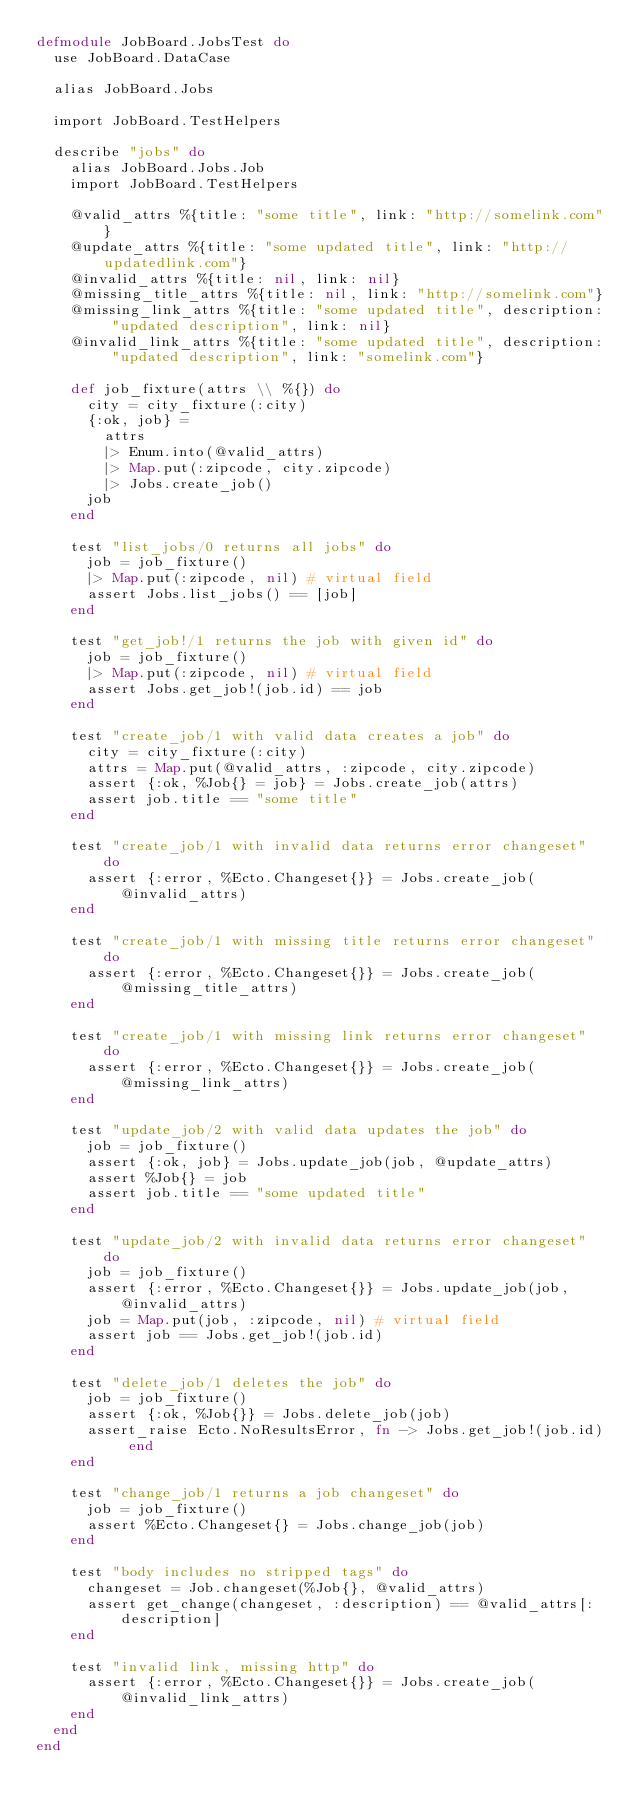<code> <loc_0><loc_0><loc_500><loc_500><_Elixir_>defmodule JobBoard.JobsTest do
  use JobBoard.DataCase

  alias JobBoard.Jobs

  import JobBoard.TestHelpers

  describe "jobs" do
    alias JobBoard.Jobs.Job
    import JobBoard.TestHelpers

    @valid_attrs %{title: "some title", link: "http://somelink.com"}
    @update_attrs %{title: "some updated title", link: "http://updatedlink.com"}
    @invalid_attrs %{title: nil, link: nil}
    @missing_title_attrs %{title: nil, link: "http://somelink.com"}
    @missing_link_attrs %{title: "some updated title", description: "updated description", link: nil}
    @invalid_link_attrs %{title: "some updated title", description: "updated description", link: "somelink.com"}

    def job_fixture(attrs \\ %{}) do
      city = city_fixture(:city)
      {:ok, job} =
        attrs
        |> Enum.into(@valid_attrs)
        |> Map.put(:zipcode, city.zipcode)
        |> Jobs.create_job()
      job
    end

    test "list_jobs/0 returns all jobs" do
      job = job_fixture()
      |> Map.put(:zipcode, nil) # virtual field
      assert Jobs.list_jobs() == [job]
    end

    test "get_job!/1 returns the job with given id" do
      job = job_fixture()
      |> Map.put(:zipcode, nil) # virtual field
      assert Jobs.get_job!(job.id) == job
    end

    test "create_job/1 with valid data creates a job" do
      city = city_fixture(:city)
      attrs = Map.put(@valid_attrs, :zipcode, city.zipcode)
      assert {:ok, %Job{} = job} = Jobs.create_job(attrs)
      assert job.title == "some title"
    end

    test "create_job/1 with invalid data returns error changeset" do
      assert {:error, %Ecto.Changeset{}} = Jobs.create_job(@invalid_attrs)
    end

    test "create_job/1 with missing title returns error changeset" do
      assert {:error, %Ecto.Changeset{}} = Jobs.create_job(@missing_title_attrs)
    end

    test "create_job/1 with missing link returns error changeset" do
      assert {:error, %Ecto.Changeset{}} = Jobs.create_job(@missing_link_attrs)
    end

    test "update_job/2 with valid data updates the job" do
      job = job_fixture()
      assert {:ok, job} = Jobs.update_job(job, @update_attrs)
      assert %Job{} = job
      assert job.title == "some updated title"
    end

    test "update_job/2 with invalid data returns error changeset" do
      job = job_fixture()
      assert {:error, %Ecto.Changeset{}} = Jobs.update_job(job, @invalid_attrs)
      job = Map.put(job, :zipcode, nil) # virtual field
      assert job == Jobs.get_job!(job.id)
    end

    test "delete_job/1 deletes the job" do
      job = job_fixture()
      assert {:ok, %Job{}} = Jobs.delete_job(job)
      assert_raise Ecto.NoResultsError, fn -> Jobs.get_job!(job.id) end
    end

    test "change_job/1 returns a job changeset" do
      job = job_fixture()
      assert %Ecto.Changeset{} = Jobs.change_job(job)
    end

    test "body includes no stripped tags" do
      changeset = Job.changeset(%Job{}, @valid_attrs)
      assert get_change(changeset, :description) == @valid_attrs[:description]
    end

    test "invalid link, missing http" do
      assert {:error, %Ecto.Changeset{}} = Jobs.create_job(@invalid_link_attrs)
    end
  end
end
</code> 